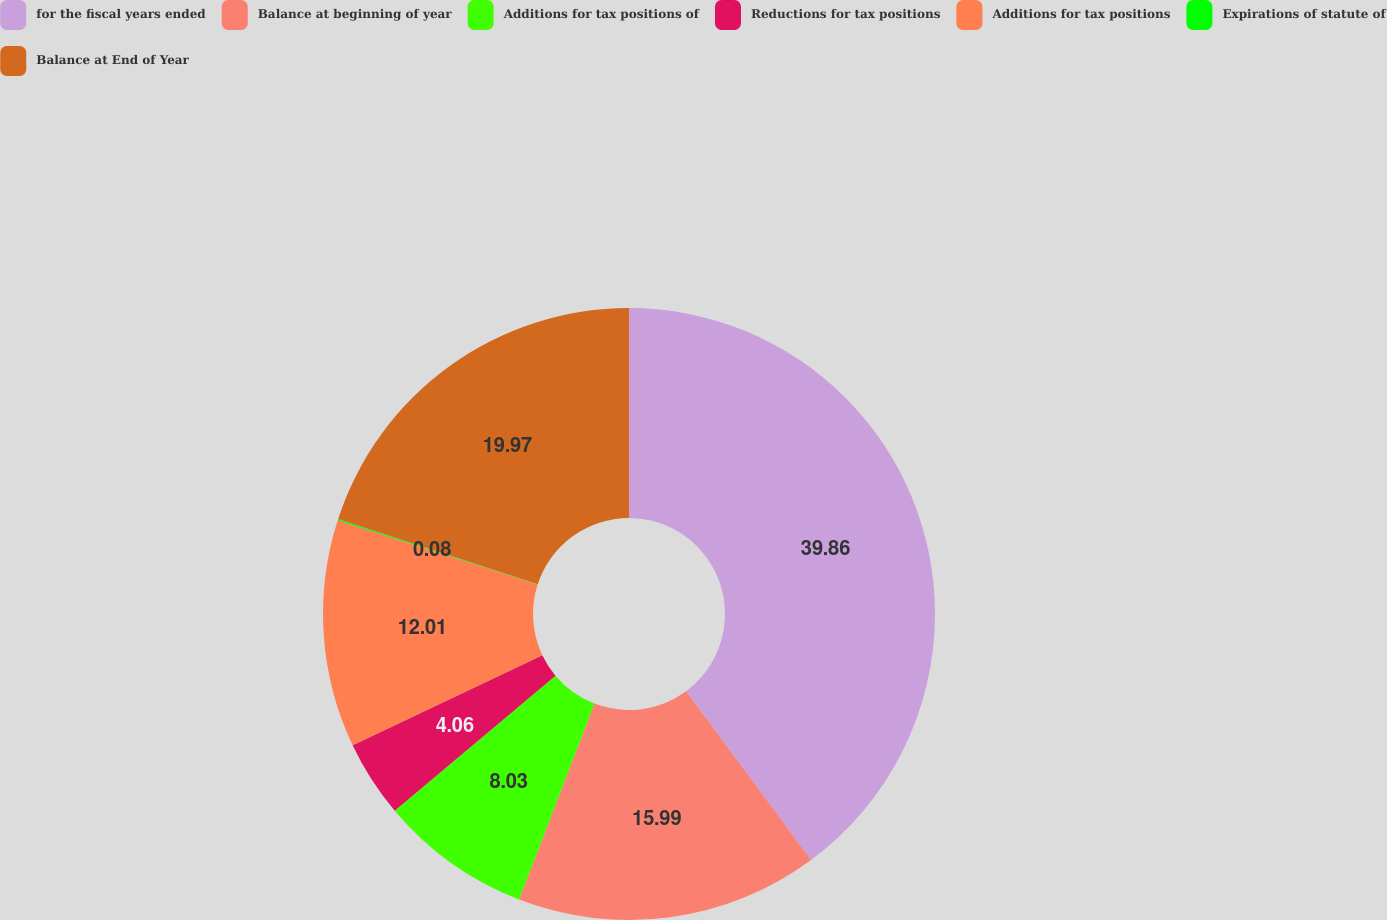Convert chart. <chart><loc_0><loc_0><loc_500><loc_500><pie_chart><fcel>for the fiscal years ended<fcel>Balance at beginning of year<fcel>Additions for tax positions of<fcel>Reductions for tax positions<fcel>Additions for tax positions<fcel>Expirations of statute of<fcel>Balance at End of Year<nl><fcel>39.86%<fcel>15.99%<fcel>8.03%<fcel>4.06%<fcel>12.01%<fcel>0.08%<fcel>19.97%<nl></chart> 